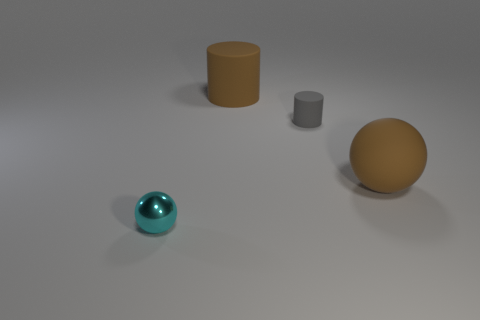Add 3 small cyan metallic balls. How many objects exist? 7 Subtract all small gray rubber things. Subtract all cyan balls. How many objects are left? 2 Add 1 large brown rubber things. How many large brown rubber things are left? 3 Add 2 small metal balls. How many small metal balls exist? 3 Subtract 0 purple cylinders. How many objects are left? 4 